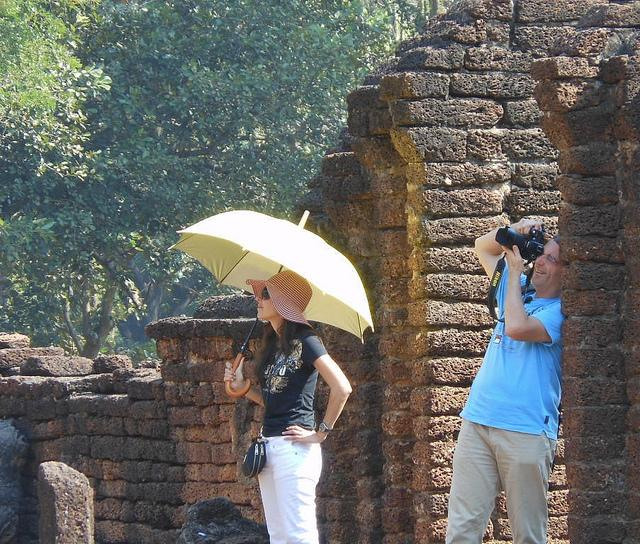What is he observing through the lens?

Choices:
A) unseen
B) himself
C) woman
D) umbrella unseen 